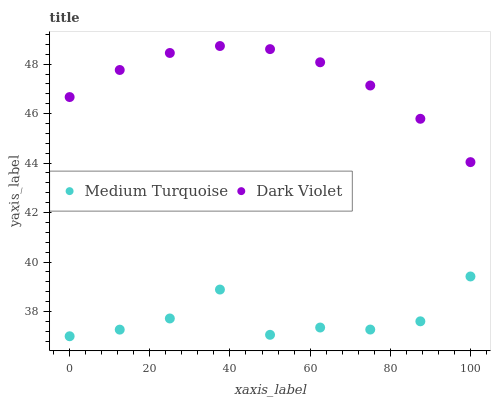Does Medium Turquoise have the minimum area under the curve?
Answer yes or no. Yes. Does Dark Violet have the maximum area under the curve?
Answer yes or no. Yes. Does Medium Turquoise have the maximum area under the curve?
Answer yes or no. No. Is Dark Violet the smoothest?
Answer yes or no. Yes. Is Medium Turquoise the roughest?
Answer yes or no. Yes. Is Medium Turquoise the smoothest?
Answer yes or no. No. Does Medium Turquoise have the lowest value?
Answer yes or no. Yes. Does Dark Violet have the highest value?
Answer yes or no. Yes. Does Medium Turquoise have the highest value?
Answer yes or no. No. Is Medium Turquoise less than Dark Violet?
Answer yes or no. Yes. Is Dark Violet greater than Medium Turquoise?
Answer yes or no. Yes. Does Medium Turquoise intersect Dark Violet?
Answer yes or no. No. 